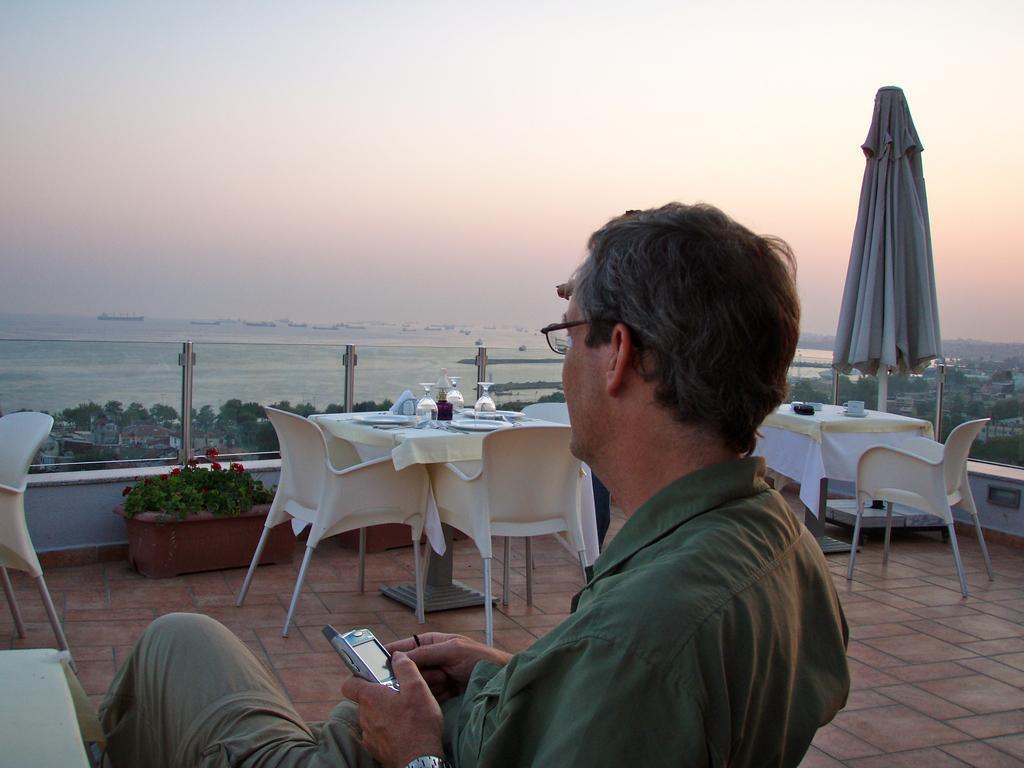Please provide a concise description of this image. In this image there is a person sitting on a chair and holding a mobile on his hand, beside him there is a table, in front of him there are few other tables with some stuff on it and chairs. In the background there is a glass railing and we can see buildings, trees, river and the sky. 